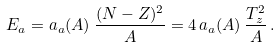Convert formula to latex. <formula><loc_0><loc_0><loc_500><loc_500>E _ { a } = a _ { a } ( A ) \, \frac { ( N - Z ) ^ { 2 } } { A } = 4 \, a _ { a } ( A ) \, \frac { T _ { z } ^ { 2 } } { A } \, .</formula> 